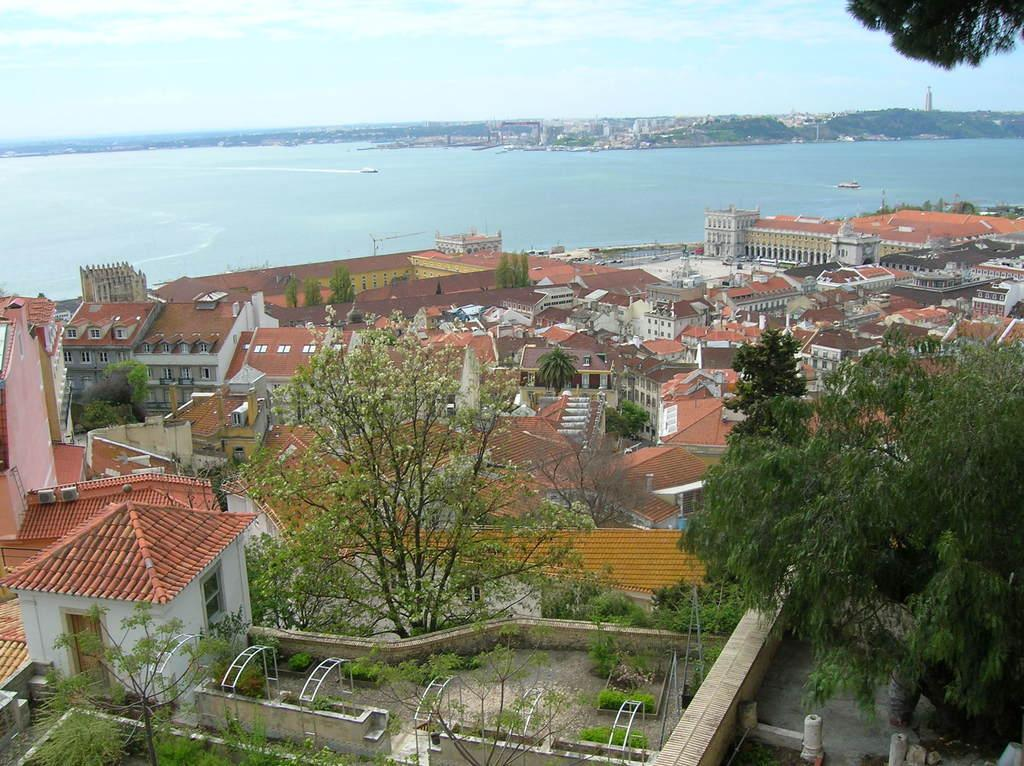What is the perspective of the image? The image shows a top view of a city. What can be seen in the city? There are many houses and trees present in the city. What natural feature is visible in the image? There is a sea visible in the image. What is the color of the sky in the image? The sky is blue in the image. What type of food is being offered to the trees in the image? There is no food being offered to the trees in the image, as trees do not consume food. 